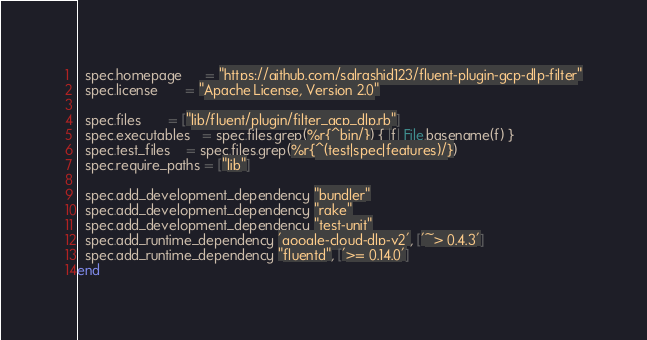Convert code to text. <code><loc_0><loc_0><loc_500><loc_500><_Ruby_>  spec.homepage      = "https://github.com/salrashid123/fluent-plugin-gcp-dlp-filter"
  spec.license       = "Apache License, Version 2.0"

  spec.files       = ["lib/fluent/plugin/filter_gcp_dlp.rb"]
  spec.executables   = spec.files.grep(%r{^bin/}) { |f| File.basename(f) }
  spec.test_files    = spec.files.grep(%r{^(test|spec|features)/})
  spec.require_paths = ["lib"]

  spec.add_development_dependency "bundler"
  spec.add_development_dependency "rake"
  spec.add_development_dependency "test-unit"
  spec.add_runtime_dependency 'google-cloud-dlp-v2', ['~> 0.4.3']
  spec.add_runtime_dependency "fluentd", ['>= 0.14.0']
end</code> 